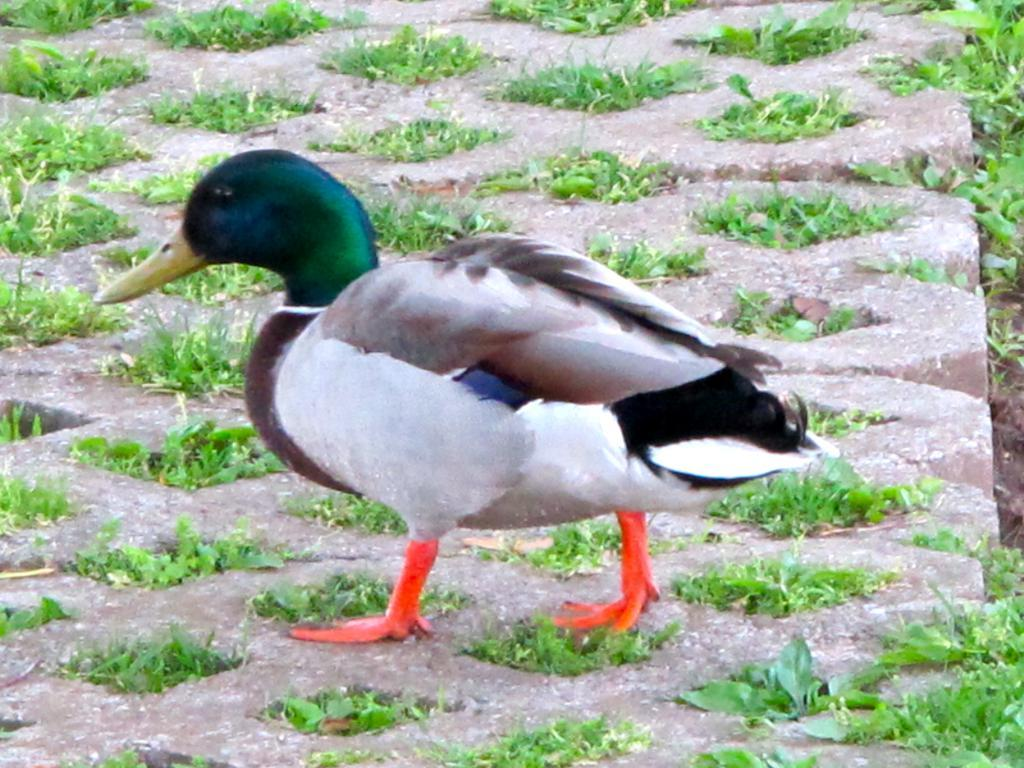What animal is in the image? There is a duck in the image. What colors can be seen on the duck? The duck has green, blue, white, brown, orange, and black colors. What type of surface is visible in the image? There is ground visible in the image. What type of vegetation is present on the ground? Small plants are present on the ground. What type of destruction can be seen in the image? There is no destruction present in the image; it features a duck with various colors and a ground with small plants. 